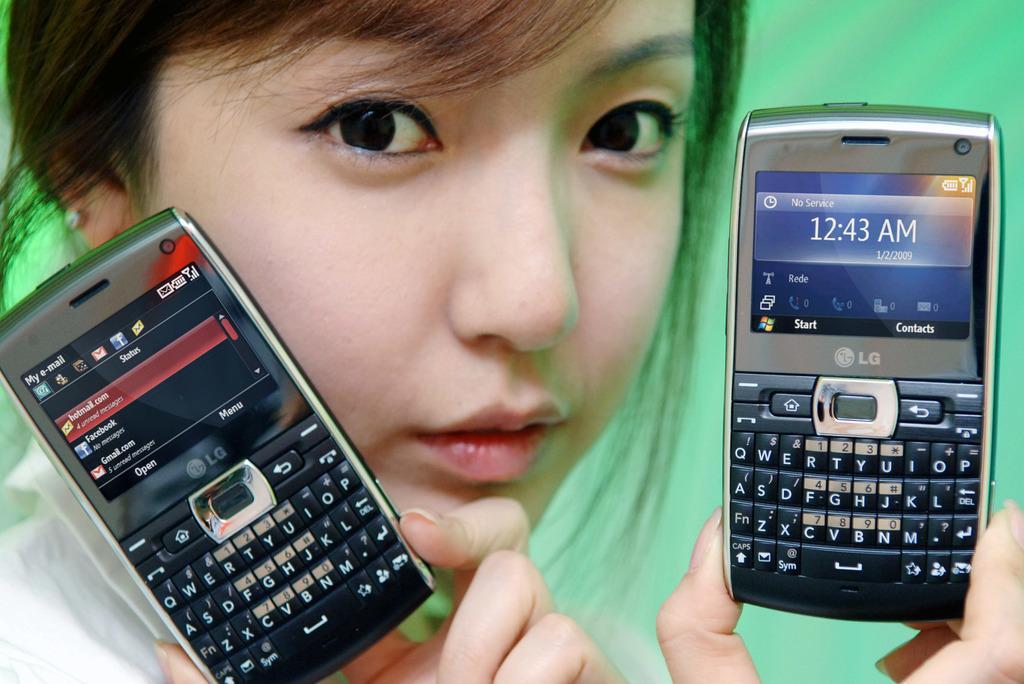In one or two sentences, can you explain what this image depicts? In this image I can see a girl and I can see she is holding two cell phones. I can also see green colour in the background. 